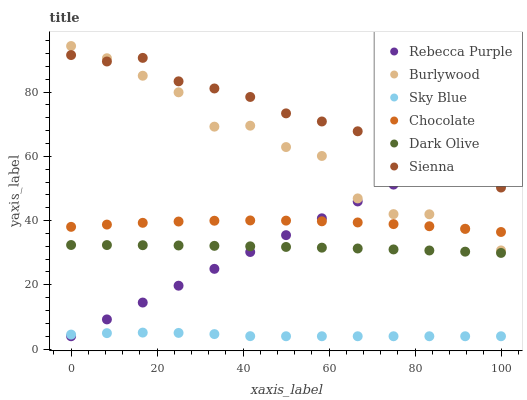Does Sky Blue have the minimum area under the curve?
Answer yes or no. Yes. Does Sienna have the maximum area under the curve?
Answer yes or no. Yes. Does Dark Olive have the minimum area under the curve?
Answer yes or no. No. Does Dark Olive have the maximum area under the curve?
Answer yes or no. No. Is Rebecca Purple the smoothest?
Answer yes or no. Yes. Is Burlywood the roughest?
Answer yes or no. Yes. Is Dark Olive the smoothest?
Answer yes or no. No. Is Dark Olive the roughest?
Answer yes or no. No. Does Rebecca Purple have the lowest value?
Answer yes or no. Yes. Does Dark Olive have the lowest value?
Answer yes or no. No. Does Burlywood have the highest value?
Answer yes or no. Yes. Does Dark Olive have the highest value?
Answer yes or no. No. Is Dark Olive less than Chocolate?
Answer yes or no. Yes. Is Chocolate greater than Dark Olive?
Answer yes or no. Yes. Does Rebecca Purple intersect Dark Olive?
Answer yes or no. Yes. Is Rebecca Purple less than Dark Olive?
Answer yes or no. No. Is Rebecca Purple greater than Dark Olive?
Answer yes or no. No. Does Dark Olive intersect Chocolate?
Answer yes or no. No. 